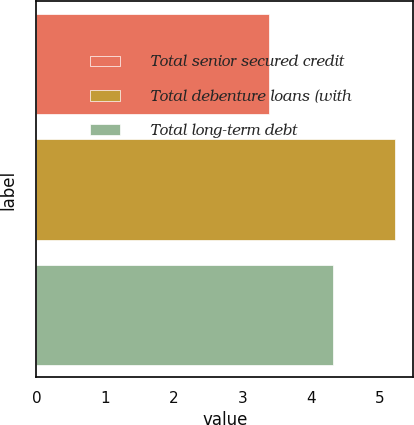Convert chart. <chart><loc_0><loc_0><loc_500><loc_500><bar_chart><fcel>Total senior secured credit<fcel>Total debenture loans (with<fcel>Total long-term debt<nl><fcel>3.39<fcel>5.22<fcel>4.32<nl></chart> 